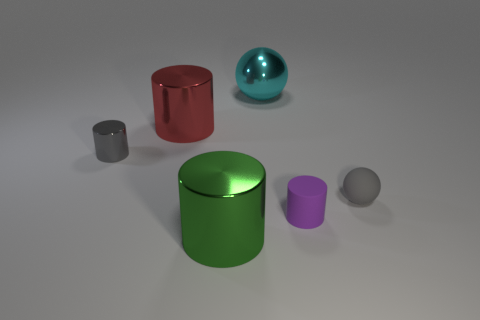How many other objects are there of the same material as the gray cylinder?
Keep it short and to the point. 3. Is the number of green metal objects right of the large red shiny thing greater than the number of cylinders that are behind the rubber cylinder?
Provide a short and direct response. No. There is a small cylinder right of the green metallic thing; what is its material?
Offer a terse response. Rubber. Is the shape of the purple rubber object the same as the green thing?
Make the answer very short. Yes. Is there anything else that has the same color as the large sphere?
Your answer should be compact. No. The other small object that is the same shape as the tiny gray metal thing is what color?
Keep it short and to the point. Purple. Is the number of gray rubber spheres that are in front of the small gray rubber object greater than the number of green rubber spheres?
Your response must be concise. No. There is a large metal cylinder in front of the small gray cylinder; what is its color?
Provide a short and direct response. Green. Is the size of the purple rubber object the same as the green shiny cylinder?
Give a very brief answer. No. The green object is what size?
Your response must be concise. Large. 